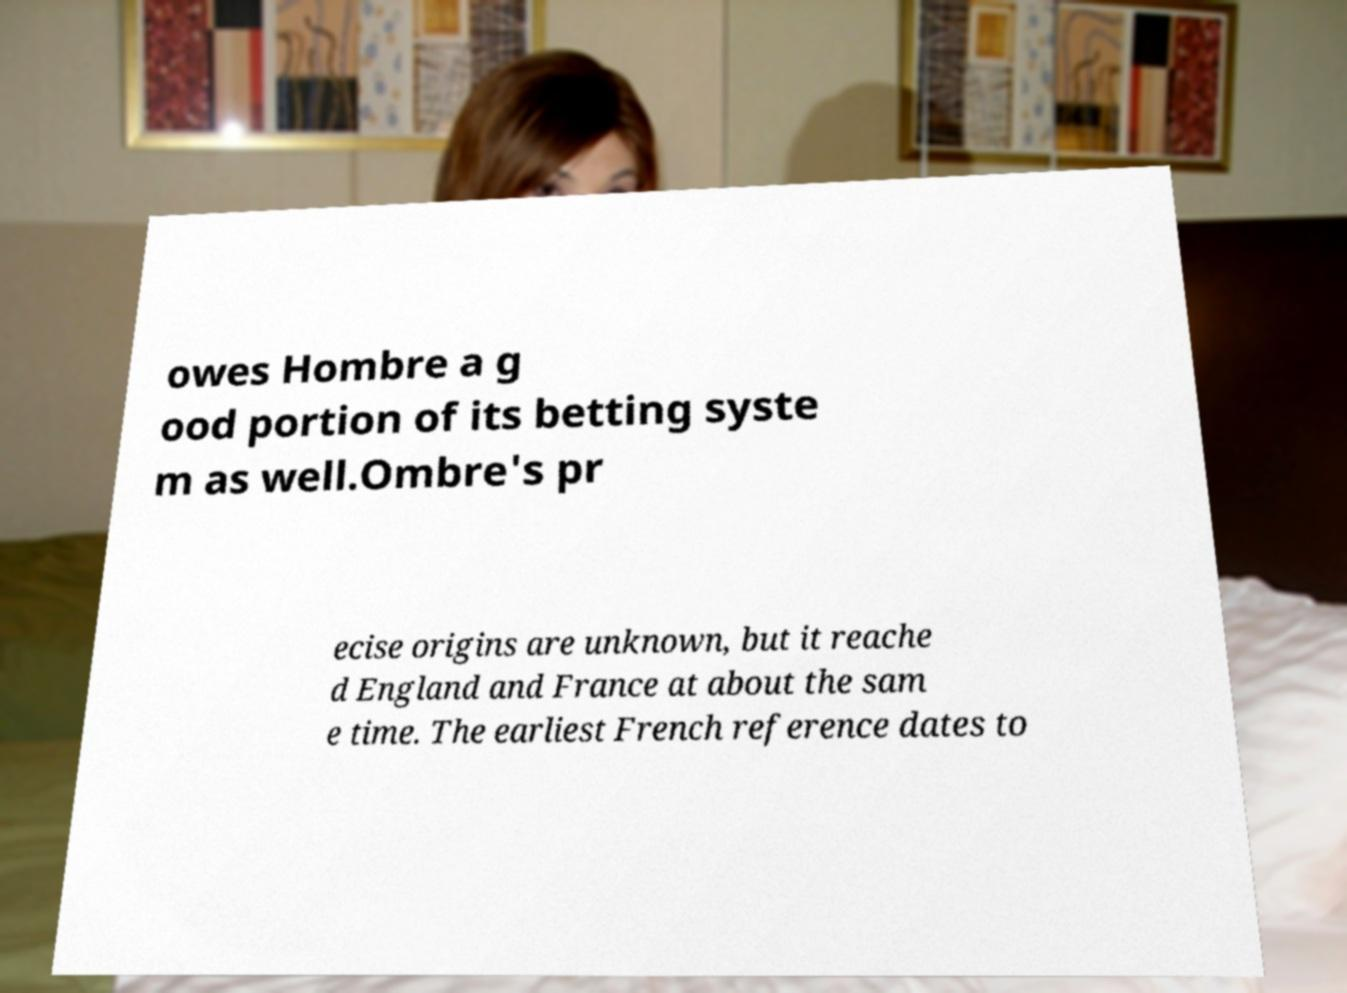Please identify and transcribe the text found in this image. owes Hombre a g ood portion of its betting syste m as well.Ombre's pr ecise origins are unknown, but it reache d England and France at about the sam e time. The earliest French reference dates to 